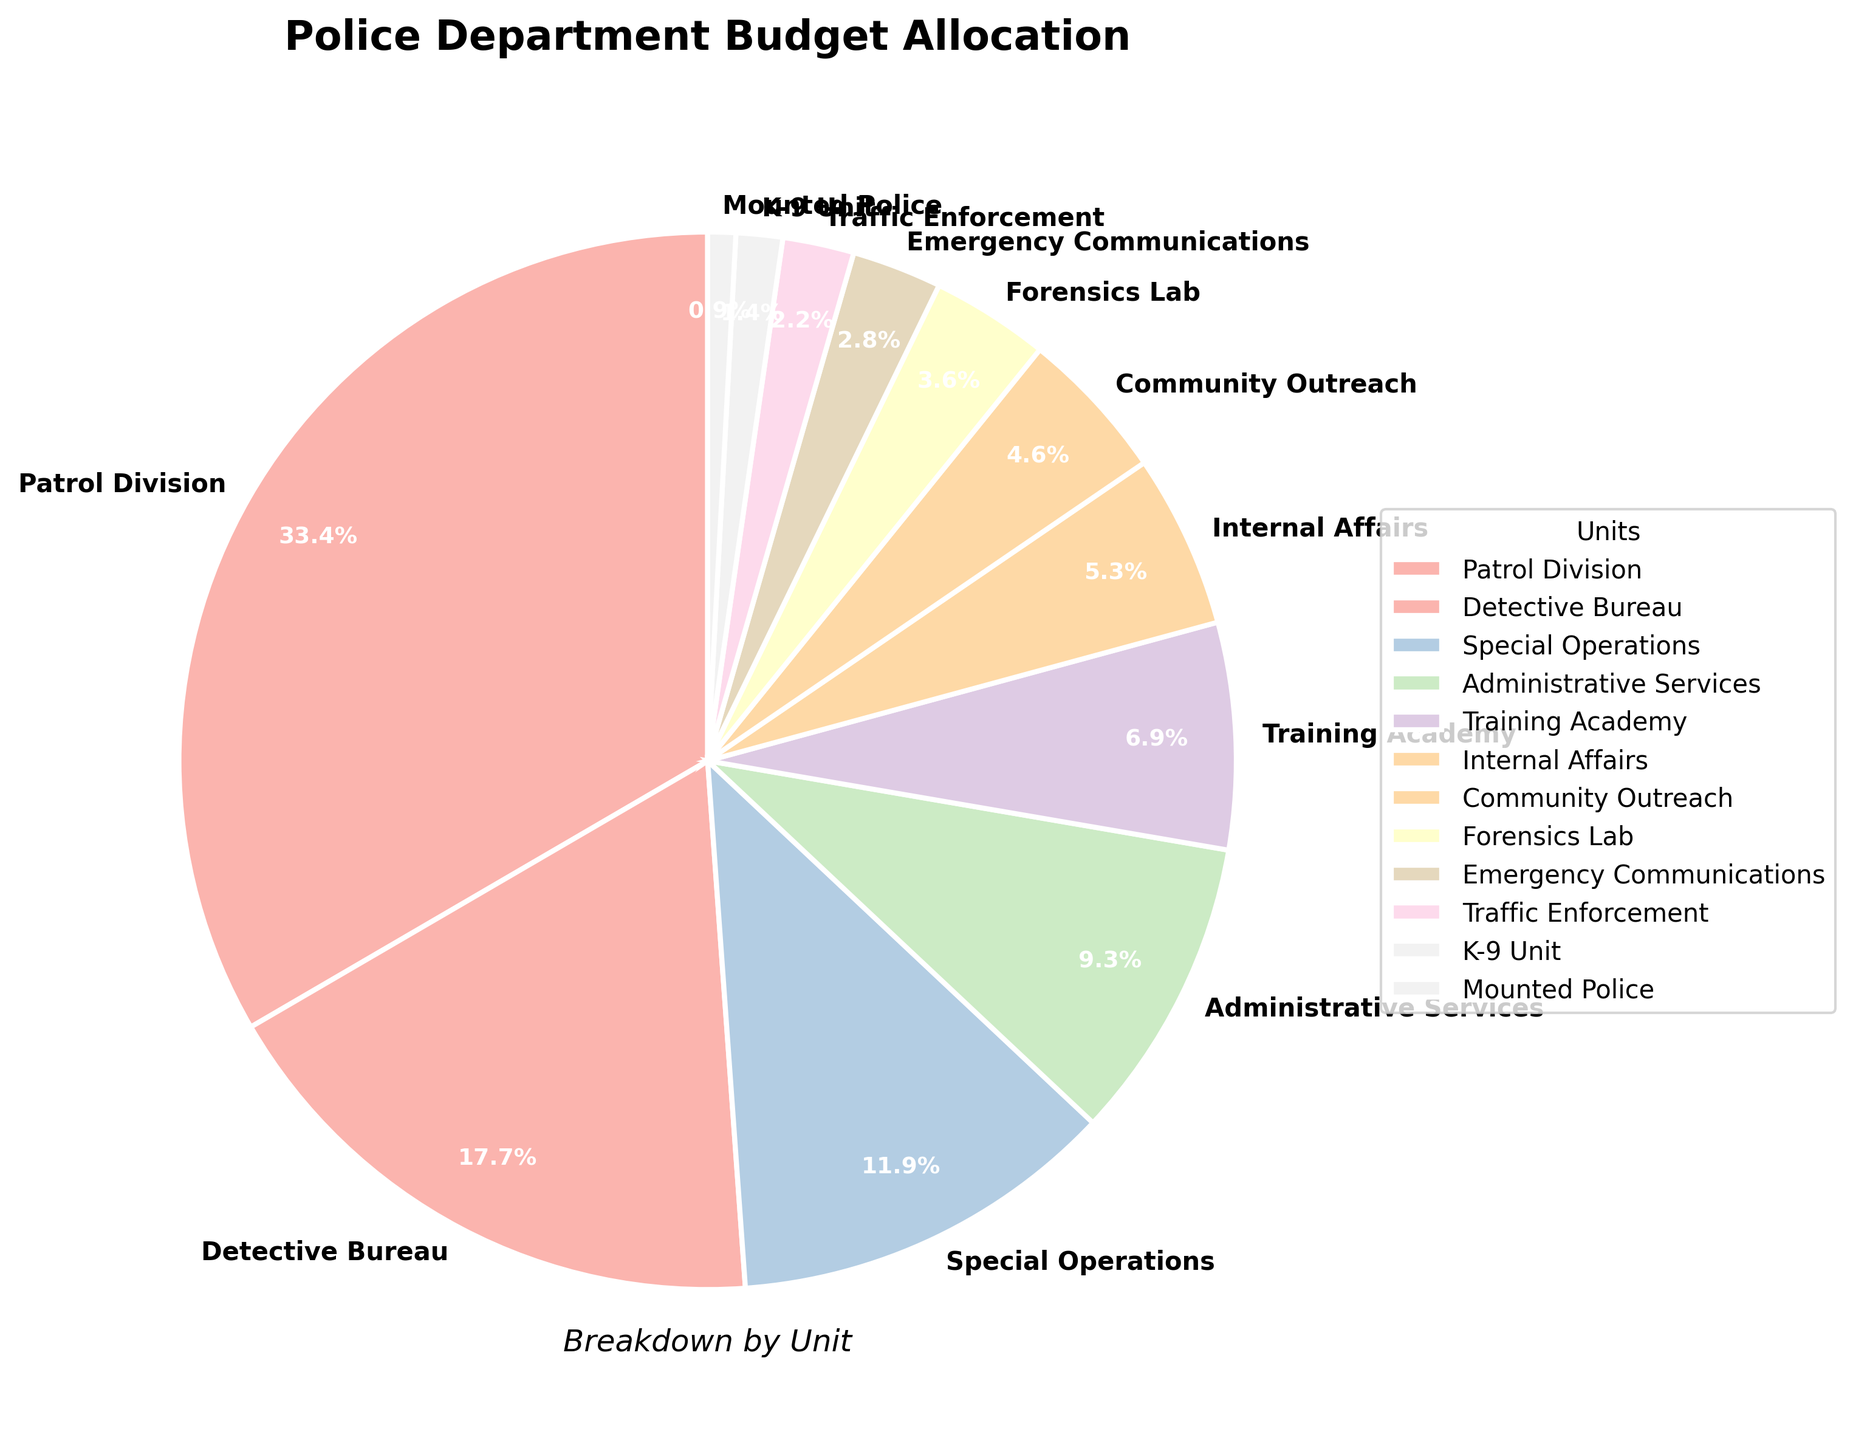Which unit has the largest budget allocation in the police department? The chart's largest slice corresponds to the Patrol Division with a budget allocation of 35.2%.
Answer: Patrol Division What is the combined budget allocation of the Detective Bureau and Special Operations units? The Detective Bureau has 18.7% and Special Operations has 12.5%. Adding these: 18.7% + 12.5% = 31.2%.
Answer: 31.2% Which unit receives less funding: Forensics Lab or Community Outreach? The pie chart shows Forensics Lab at 3.8% and Community Outreach at 4.9%. Since 3.8% is less than 4.9%, the Forensics Lab receives less funding.
Answer: Forensics Lab What is the difference in budget allocation between the largest and smallest units? The largest allocation is for Patrol Division at 35.2% and the smallest is Mounted Police at 0.9%. The difference is 35.2% - 0.9% = 34.3%.
Answer: 34.3% How much more is allocated to the Training Academy than to the Emergency Communications unit? Training Academy is allocated 7.3%, and Emergency Communications is allocated 2.9%. The difference is 7.3% - 2.9% = 4.4%.
Answer: 4.4% What color is used for the K-9 Unit in the pie chart? In the pie chart, the K-9 Unit is represented by a specific color from the Pastel1 color palette used in the chart.
Answer: (Answer would be a specific color visible in the chart, e.g., "light pink") How does the allocation for Internal Affairs compare to Traffic Enforcement? Internal Affairs has 5.6% and Traffic Enforcement has 2.3%. Compared to Traffic Enforcement, Internal Affairs has a greater allocation.
Answer: Internal Affairs Is the budget for Administrative Services higher, lower, or equal to that of Special Operations? Administrative Services has 9.8% and Special Operations has 12.5%. Thus, the budget for Administrative Services is lower.
Answer: Lower What are the top three units in terms of budget allocation? The top three units by budget allocation are Patrol Division (35.2%), Detective Bureau (18.7%), and Special Operations (12.5%).
Answer: Patrol Division, Detective Bureau, Special Operations What proportion of the overall budget is allocated to units other than Patrol Division and Detective Bureau? The total budget percentage excluding Patrol Division (35.2%) and Detective Bureau (18.7%) is 100% - 35.2% - 18.7% = 46.1%.
Answer: 46.1% 